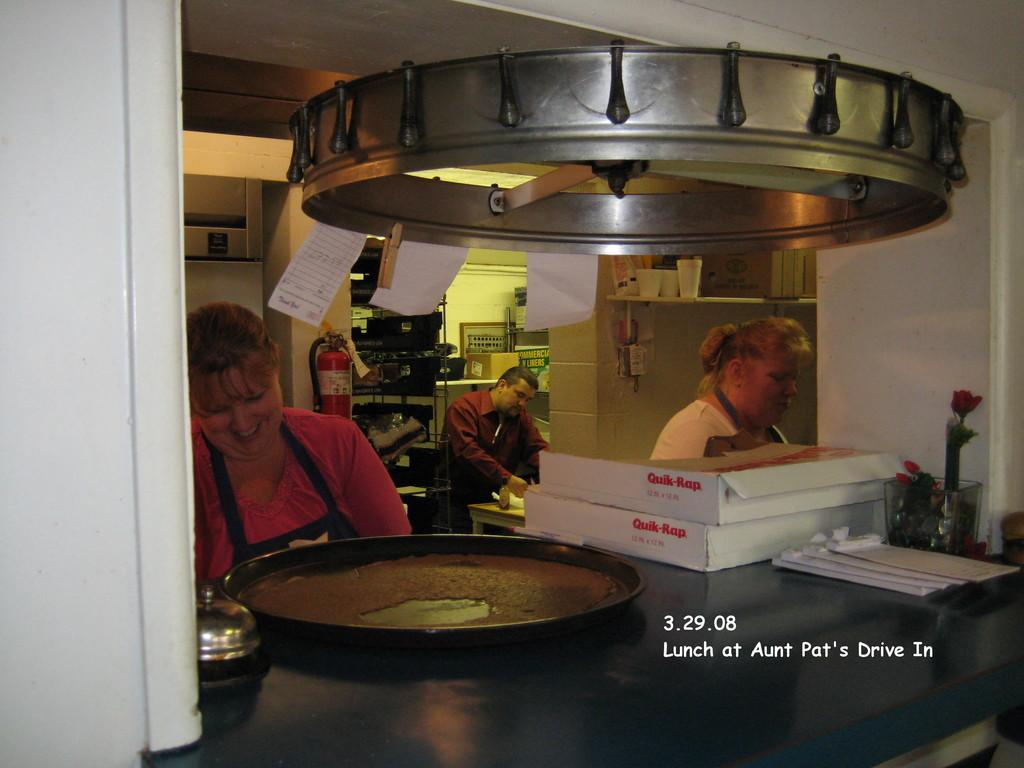<image>
Relay a brief, clear account of the picture shown. Two women and a man in a restaurant kitchen preparing food on 3.29.08. 